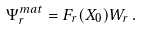Convert formula to latex. <formula><loc_0><loc_0><loc_500><loc_500>\Psi _ { r } ^ { m a t } = F _ { r } ( X _ { 0 } ) W _ { r } \, .</formula> 